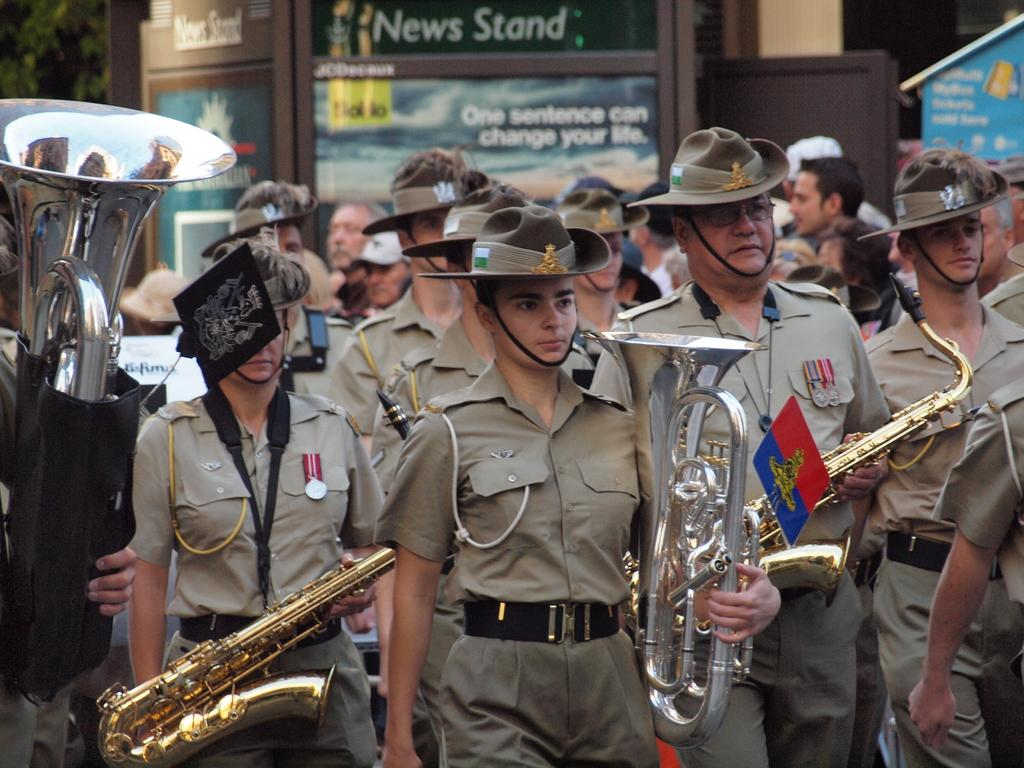What type of people can be seen in the image? There are police officers in the image. What are the police officers doing in the image? The police officers are holding musical instruments. What natural element is visible in the image? There is a tree visible in the top left side of the image. What type of pipe is being played by the police officers in the image? There is no pipe being played by the police officers in the image; they are holding musical instruments, but no specific instrument is mentioned. 